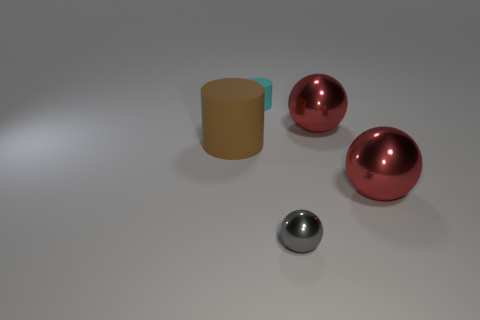Does the gray shiny ball have the same size as the brown matte cylinder?
Your response must be concise. No. What material is the small thing that is right of the small thing that is on the left side of the tiny gray ball made of?
Provide a succinct answer. Metal. Is the number of rubber things that are on the left side of the brown cylinder less than the number of purple balls?
Offer a very short reply. No. What color is the matte object that is in front of the tiny object behind the gray shiny sphere?
Keep it short and to the point. Brown. What size is the rubber object that is in front of the big shiny object behind the rubber object in front of the cyan rubber thing?
Keep it short and to the point. Large. Are there fewer big cylinders to the right of the big brown matte cylinder than small objects behind the small gray shiny sphere?
Your answer should be compact. Yes. How many tiny things are made of the same material as the large cylinder?
Offer a very short reply. 1. There is a cylinder that is in front of the small object that is behind the small metal object; is there a matte cylinder that is behind it?
Make the answer very short. Yes. There is a cyan object that is made of the same material as the brown object; what is its shape?
Provide a succinct answer. Cylinder. Are there more large yellow objects than spheres?
Your response must be concise. No. 